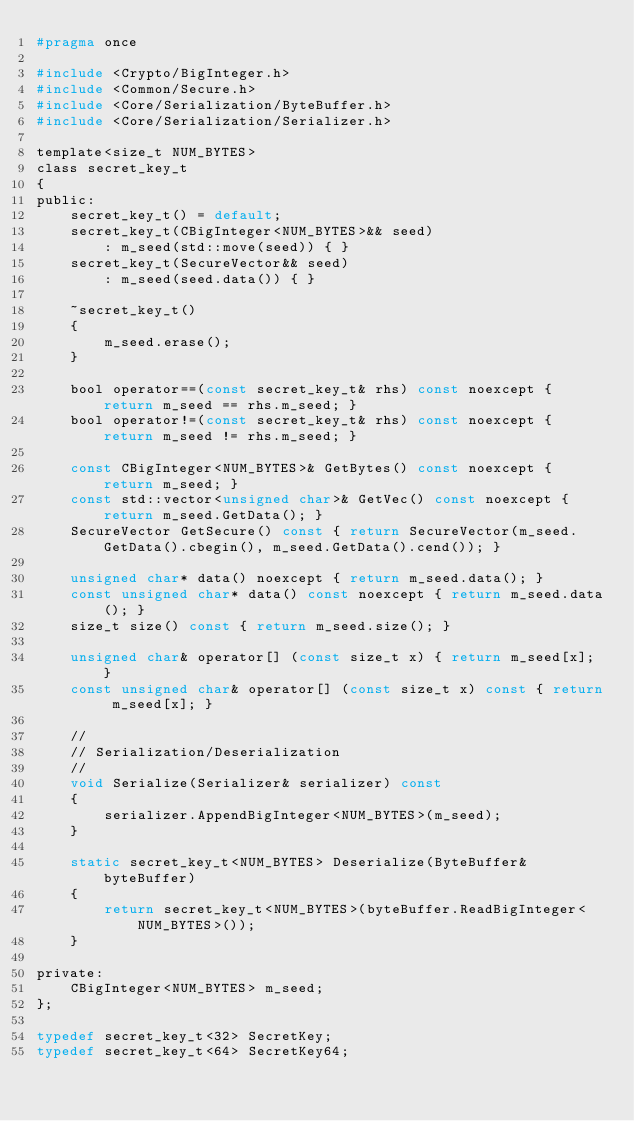<code> <loc_0><loc_0><loc_500><loc_500><_C_>#pragma once

#include <Crypto/BigInteger.h>
#include <Common/Secure.h>
#include <Core/Serialization/ByteBuffer.h>
#include <Core/Serialization/Serializer.h>

template<size_t NUM_BYTES>
class secret_key_t
{
public:
	secret_key_t() = default;
	secret_key_t(CBigInteger<NUM_BYTES>&& seed)
		: m_seed(std::move(seed)) { }
	secret_key_t(SecureVector&& seed)
		: m_seed(seed.data()) { }

	~secret_key_t()
	{
		m_seed.erase();
	}

	bool operator==(const secret_key_t& rhs) const noexcept { return m_seed == rhs.m_seed; }
	bool operator!=(const secret_key_t& rhs) const noexcept { return m_seed != rhs.m_seed; }

	const CBigInteger<NUM_BYTES>& GetBytes() const noexcept { return m_seed; }
	const std::vector<unsigned char>& GetVec() const noexcept { return m_seed.GetData(); }
	SecureVector GetSecure() const { return SecureVector(m_seed.GetData().cbegin(), m_seed.GetData().cend()); }

	unsigned char* data() noexcept { return m_seed.data(); }
	const unsigned char* data() const noexcept { return m_seed.data(); }
	size_t size() const { return m_seed.size(); }

	unsigned char& operator[] (const size_t x) { return m_seed[x]; }
	const unsigned char& operator[] (const size_t x) const { return m_seed[x]; }

	//
	// Serialization/Deserialization
	//
	void Serialize(Serializer& serializer) const
	{
		serializer.AppendBigInteger<NUM_BYTES>(m_seed);
	}

	static secret_key_t<NUM_BYTES> Deserialize(ByteBuffer& byteBuffer)
	{
		return secret_key_t<NUM_BYTES>(byteBuffer.ReadBigInteger<NUM_BYTES>());
	}

private:
	CBigInteger<NUM_BYTES> m_seed;
};

typedef secret_key_t<32> SecretKey;
typedef secret_key_t<64> SecretKey64;</code> 